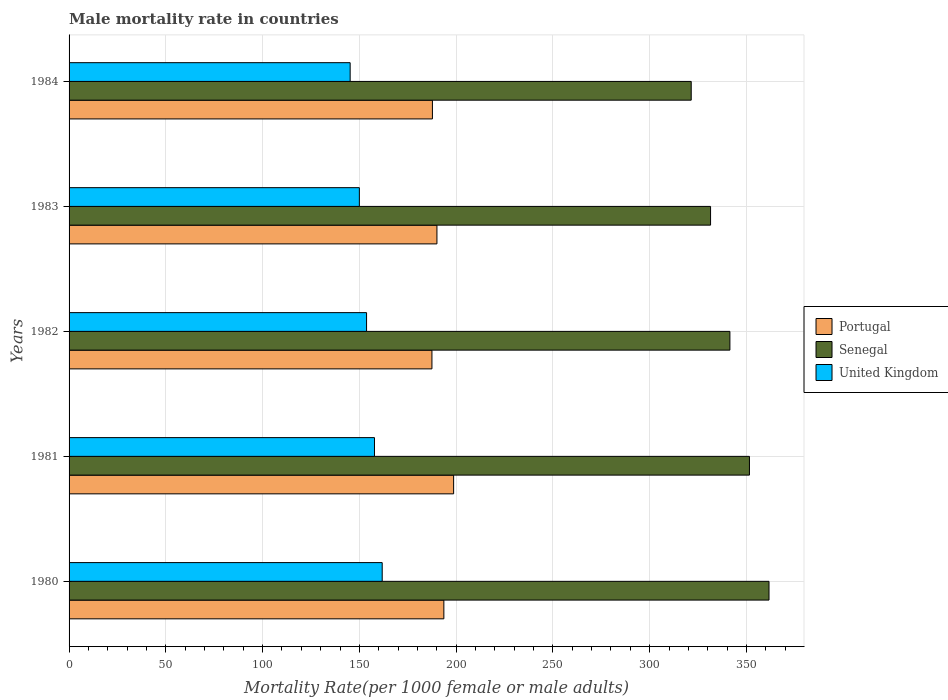How many different coloured bars are there?
Offer a very short reply. 3. Are the number of bars on each tick of the Y-axis equal?
Ensure brevity in your answer.  Yes. What is the label of the 5th group of bars from the top?
Offer a terse response. 1980. What is the male mortality rate in Senegal in 1984?
Make the answer very short. 321.48. Across all years, what is the maximum male mortality rate in Senegal?
Keep it short and to the point. 361.68. Across all years, what is the minimum male mortality rate in Senegal?
Make the answer very short. 321.48. What is the total male mortality rate in Portugal in the graph?
Ensure brevity in your answer.  957.71. What is the difference between the male mortality rate in United Kingdom in 1982 and that in 1983?
Your response must be concise. 3.72. What is the difference between the male mortality rate in Portugal in 1983 and the male mortality rate in Senegal in 1982?
Ensure brevity in your answer.  -151.38. What is the average male mortality rate in Senegal per year?
Make the answer very short. 341.53. In the year 1983, what is the difference between the male mortality rate in Senegal and male mortality rate in United Kingdom?
Give a very brief answer. 181.47. In how many years, is the male mortality rate in Senegal greater than 210 ?
Your answer should be very brief. 5. What is the ratio of the male mortality rate in Portugal in 1982 to that in 1983?
Your answer should be compact. 0.99. What is the difference between the highest and the second highest male mortality rate in Portugal?
Offer a very short reply. 5.04. What is the difference between the highest and the lowest male mortality rate in United Kingdom?
Ensure brevity in your answer.  16.56. Is the sum of the male mortality rate in Senegal in 1982 and 1983 greater than the maximum male mortality rate in Portugal across all years?
Make the answer very short. Yes. What does the 3rd bar from the top in 1984 represents?
Provide a succinct answer. Portugal. What does the 2nd bar from the bottom in 1980 represents?
Make the answer very short. Senegal. How many bars are there?
Offer a very short reply. 15. Are all the bars in the graph horizontal?
Provide a short and direct response. Yes. Are the values on the major ticks of X-axis written in scientific E-notation?
Make the answer very short. No. Does the graph contain grids?
Keep it short and to the point. Yes. Where does the legend appear in the graph?
Provide a succinct answer. Center right. What is the title of the graph?
Your answer should be very brief. Male mortality rate in countries. What is the label or title of the X-axis?
Ensure brevity in your answer.  Mortality Rate(per 1000 female or male adults). What is the label or title of the Y-axis?
Your answer should be very brief. Years. What is the Mortality Rate(per 1000 female or male adults) of Portugal in 1980?
Offer a terse response. 193.66. What is the Mortality Rate(per 1000 female or male adults) of Senegal in 1980?
Your answer should be very brief. 361.68. What is the Mortality Rate(per 1000 female or male adults) in United Kingdom in 1980?
Make the answer very short. 161.8. What is the Mortality Rate(per 1000 female or male adults) of Portugal in 1981?
Your answer should be compact. 198.71. What is the Mortality Rate(per 1000 female or male adults) of Senegal in 1981?
Keep it short and to the point. 351.57. What is the Mortality Rate(per 1000 female or male adults) of United Kingdom in 1981?
Provide a short and direct response. 157.82. What is the Mortality Rate(per 1000 female or male adults) of Portugal in 1982?
Offer a terse response. 187.5. What is the Mortality Rate(per 1000 female or male adults) in Senegal in 1982?
Provide a short and direct response. 341.47. What is the Mortality Rate(per 1000 female or male adults) in United Kingdom in 1982?
Ensure brevity in your answer.  153.72. What is the Mortality Rate(per 1000 female or male adults) in Portugal in 1983?
Your response must be concise. 190.09. What is the Mortality Rate(per 1000 female or male adults) in Senegal in 1983?
Your answer should be compact. 331.47. What is the Mortality Rate(per 1000 female or male adults) in United Kingdom in 1983?
Your answer should be compact. 150. What is the Mortality Rate(per 1000 female or male adults) of Portugal in 1984?
Your answer should be very brief. 187.75. What is the Mortality Rate(per 1000 female or male adults) of Senegal in 1984?
Give a very brief answer. 321.48. What is the Mortality Rate(per 1000 female or male adults) in United Kingdom in 1984?
Provide a short and direct response. 145.24. Across all years, what is the maximum Mortality Rate(per 1000 female or male adults) in Portugal?
Your response must be concise. 198.71. Across all years, what is the maximum Mortality Rate(per 1000 female or male adults) in Senegal?
Give a very brief answer. 361.68. Across all years, what is the maximum Mortality Rate(per 1000 female or male adults) of United Kingdom?
Provide a short and direct response. 161.8. Across all years, what is the minimum Mortality Rate(per 1000 female or male adults) of Portugal?
Provide a short and direct response. 187.5. Across all years, what is the minimum Mortality Rate(per 1000 female or male adults) in Senegal?
Your answer should be compact. 321.48. Across all years, what is the minimum Mortality Rate(per 1000 female or male adults) of United Kingdom?
Give a very brief answer. 145.24. What is the total Mortality Rate(per 1000 female or male adults) in Portugal in the graph?
Your response must be concise. 957.71. What is the total Mortality Rate(per 1000 female or male adults) of Senegal in the graph?
Your answer should be compact. 1707.67. What is the total Mortality Rate(per 1000 female or male adults) of United Kingdom in the graph?
Give a very brief answer. 768.59. What is the difference between the Mortality Rate(per 1000 female or male adults) in Portugal in 1980 and that in 1981?
Make the answer very short. -5.04. What is the difference between the Mortality Rate(per 1000 female or male adults) in Senegal in 1980 and that in 1981?
Your response must be concise. 10.1. What is the difference between the Mortality Rate(per 1000 female or male adults) of United Kingdom in 1980 and that in 1981?
Keep it short and to the point. 3.99. What is the difference between the Mortality Rate(per 1000 female or male adults) in Portugal in 1980 and that in 1982?
Your answer should be compact. 6.16. What is the difference between the Mortality Rate(per 1000 female or male adults) in Senegal in 1980 and that in 1982?
Make the answer very short. 20.21. What is the difference between the Mortality Rate(per 1000 female or male adults) of United Kingdom in 1980 and that in 1982?
Your response must be concise. 8.08. What is the difference between the Mortality Rate(per 1000 female or male adults) of Portugal in 1980 and that in 1983?
Your answer should be compact. 3.57. What is the difference between the Mortality Rate(per 1000 female or male adults) in Senegal in 1980 and that in 1983?
Your response must be concise. 30.2. What is the difference between the Mortality Rate(per 1000 female or male adults) in United Kingdom in 1980 and that in 1983?
Your answer should be compact. 11.8. What is the difference between the Mortality Rate(per 1000 female or male adults) of Portugal in 1980 and that in 1984?
Offer a terse response. 5.91. What is the difference between the Mortality Rate(per 1000 female or male adults) of Senegal in 1980 and that in 1984?
Give a very brief answer. 40.2. What is the difference between the Mortality Rate(per 1000 female or male adults) of United Kingdom in 1980 and that in 1984?
Make the answer very short. 16.56. What is the difference between the Mortality Rate(per 1000 female or male adults) of Portugal in 1981 and that in 1982?
Your answer should be very brief. 11.21. What is the difference between the Mortality Rate(per 1000 female or male adults) in Senegal in 1981 and that in 1982?
Your answer should be compact. 10.1. What is the difference between the Mortality Rate(per 1000 female or male adults) of United Kingdom in 1981 and that in 1982?
Offer a very short reply. 4.09. What is the difference between the Mortality Rate(per 1000 female or male adults) of Portugal in 1981 and that in 1983?
Offer a terse response. 8.62. What is the difference between the Mortality Rate(per 1000 female or male adults) of Senegal in 1981 and that in 1983?
Make the answer very short. 20.1. What is the difference between the Mortality Rate(per 1000 female or male adults) in United Kingdom in 1981 and that in 1983?
Your answer should be compact. 7.81. What is the difference between the Mortality Rate(per 1000 female or male adults) in Portugal in 1981 and that in 1984?
Provide a succinct answer. 10.95. What is the difference between the Mortality Rate(per 1000 female or male adults) of Senegal in 1981 and that in 1984?
Ensure brevity in your answer.  30.09. What is the difference between the Mortality Rate(per 1000 female or male adults) of United Kingdom in 1981 and that in 1984?
Make the answer very short. 12.57. What is the difference between the Mortality Rate(per 1000 female or male adults) of Portugal in 1982 and that in 1983?
Provide a succinct answer. -2.59. What is the difference between the Mortality Rate(per 1000 female or male adults) in Senegal in 1982 and that in 1983?
Offer a terse response. 9.99. What is the difference between the Mortality Rate(per 1000 female or male adults) of United Kingdom in 1982 and that in 1983?
Give a very brief answer. 3.72. What is the difference between the Mortality Rate(per 1000 female or male adults) in Portugal in 1982 and that in 1984?
Your answer should be very brief. -0.26. What is the difference between the Mortality Rate(per 1000 female or male adults) in Senegal in 1982 and that in 1984?
Give a very brief answer. 19.99. What is the difference between the Mortality Rate(per 1000 female or male adults) in United Kingdom in 1982 and that in 1984?
Your answer should be compact. 8.48. What is the difference between the Mortality Rate(per 1000 female or male adults) in Portugal in 1983 and that in 1984?
Give a very brief answer. 2.33. What is the difference between the Mortality Rate(per 1000 female or male adults) in Senegal in 1983 and that in 1984?
Give a very brief answer. 9.99. What is the difference between the Mortality Rate(per 1000 female or male adults) in United Kingdom in 1983 and that in 1984?
Your response must be concise. 4.76. What is the difference between the Mortality Rate(per 1000 female or male adults) in Portugal in 1980 and the Mortality Rate(per 1000 female or male adults) in Senegal in 1981?
Your response must be concise. -157.91. What is the difference between the Mortality Rate(per 1000 female or male adults) of Portugal in 1980 and the Mortality Rate(per 1000 female or male adults) of United Kingdom in 1981?
Keep it short and to the point. 35.84. What is the difference between the Mortality Rate(per 1000 female or male adults) in Senegal in 1980 and the Mortality Rate(per 1000 female or male adults) in United Kingdom in 1981?
Make the answer very short. 203.86. What is the difference between the Mortality Rate(per 1000 female or male adults) in Portugal in 1980 and the Mortality Rate(per 1000 female or male adults) in Senegal in 1982?
Your answer should be compact. -147.81. What is the difference between the Mortality Rate(per 1000 female or male adults) of Portugal in 1980 and the Mortality Rate(per 1000 female or male adults) of United Kingdom in 1982?
Your response must be concise. 39.94. What is the difference between the Mortality Rate(per 1000 female or male adults) of Senegal in 1980 and the Mortality Rate(per 1000 female or male adults) of United Kingdom in 1982?
Your response must be concise. 207.95. What is the difference between the Mortality Rate(per 1000 female or male adults) in Portugal in 1980 and the Mortality Rate(per 1000 female or male adults) in Senegal in 1983?
Keep it short and to the point. -137.81. What is the difference between the Mortality Rate(per 1000 female or male adults) of Portugal in 1980 and the Mortality Rate(per 1000 female or male adults) of United Kingdom in 1983?
Make the answer very short. 43.66. What is the difference between the Mortality Rate(per 1000 female or male adults) of Senegal in 1980 and the Mortality Rate(per 1000 female or male adults) of United Kingdom in 1983?
Your response must be concise. 211.67. What is the difference between the Mortality Rate(per 1000 female or male adults) of Portugal in 1980 and the Mortality Rate(per 1000 female or male adults) of Senegal in 1984?
Offer a very short reply. -127.82. What is the difference between the Mortality Rate(per 1000 female or male adults) in Portugal in 1980 and the Mortality Rate(per 1000 female or male adults) in United Kingdom in 1984?
Your answer should be very brief. 48.42. What is the difference between the Mortality Rate(per 1000 female or male adults) of Senegal in 1980 and the Mortality Rate(per 1000 female or male adults) of United Kingdom in 1984?
Provide a succinct answer. 216.43. What is the difference between the Mortality Rate(per 1000 female or male adults) in Portugal in 1981 and the Mortality Rate(per 1000 female or male adults) in Senegal in 1982?
Make the answer very short. -142.76. What is the difference between the Mortality Rate(per 1000 female or male adults) of Portugal in 1981 and the Mortality Rate(per 1000 female or male adults) of United Kingdom in 1982?
Keep it short and to the point. 44.98. What is the difference between the Mortality Rate(per 1000 female or male adults) of Senegal in 1981 and the Mortality Rate(per 1000 female or male adults) of United Kingdom in 1982?
Give a very brief answer. 197.85. What is the difference between the Mortality Rate(per 1000 female or male adults) of Portugal in 1981 and the Mortality Rate(per 1000 female or male adults) of Senegal in 1983?
Provide a succinct answer. -132.77. What is the difference between the Mortality Rate(per 1000 female or male adults) of Portugal in 1981 and the Mortality Rate(per 1000 female or male adults) of United Kingdom in 1983?
Offer a terse response. 48.7. What is the difference between the Mortality Rate(per 1000 female or male adults) in Senegal in 1981 and the Mortality Rate(per 1000 female or male adults) in United Kingdom in 1983?
Your answer should be compact. 201.57. What is the difference between the Mortality Rate(per 1000 female or male adults) in Portugal in 1981 and the Mortality Rate(per 1000 female or male adults) in Senegal in 1984?
Give a very brief answer. -122.77. What is the difference between the Mortality Rate(per 1000 female or male adults) of Portugal in 1981 and the Mortality Rate(per 1000 female or male adults) of United Kingdom in 1984?
Provide a short and direct response. 53.46. What is the difference between the Mortality Rate(per 1000 female or male adults) in Senegal in 1981 and the Mortality Rate(per 1000 female or male adults) in United Kingdom in 1984?
Your response must be concise. 206.33. What is the difference between the Mortality Rate(per 1000 female or male adults) of Portugal in 1982 and the Mortality Rate(per 1000 female or male adults) of Senegal in 1983?
Your answer should be very brief. -143.98. What is the difference between the Mortality Rate(per 1000 female or male adults) of Portugal in 1982 and the Mortality Rate(per 1000 female or male adults) of United Kingdom in 1983?
Ensure brevity in your answer.  37.49. What is the difference between the Mortality Rate(per 1000 female or male adults) in Senegal in 1982 and the Mortality Rate(per 1000 female or male adults) in United Kingdom in 1983?
Provide a short and direct response. 191.47. What is the difference between the Mortality Rate(per 1000 female or male adults) of Portugal in 1982 and the Mortality Rate(per 1000 female or male adults) of Senegal in 1984?
Your answer should be very brief. -133.98. What is the difference between the Mortality Rate(per 1000 female or male adults) in Portugal in 1982 and the Mortality Rate(per 1000 female or male adults) in United Kingdom in 1984?
Give a very brief answer. 42.25. What is the difference between the Mortality Rate(per 1000 female or male adults) in Senegal in 1982 and the Mortality Rate(per 1000 female or male adults) in United Kingdom in 1984?
Your response must be concise. 196.22. What is the difference between the Mortality Rate(per 1000 female or male adults) of Portugal in 1983 and the Mortality Rate(per 1000 female or male adults) of Senegal in 1984?
Your response must be concise. -131.39. What is the difference between the Mortality Rate(per 1000 female or male adults) of Portugal in 1983 and the Mortality Rate(per 1000 female or male adults) of United Kingdom in 1984?
Offer a very short reply. 44.84. What is the difference between the Mortality Rate(per 1000 female or male adults) in Senegal in 1983 and the Mortality Rate(per 1000 female or male adults) in United Kingdom in 1984?
Offer a very short reply. 186.23. What is the average Mortality Rate(per 1000 female or male adults) of Portugal per year?
Keep it short and to the point. 191.54. What is the average Mortality Rate(per 1000 female or male adults) of Senegal per year?
Offer a terse response. 341.53. What is the average Mortality Rate(per 1000 female or male adults) in United Kingdom per year?
Provide a short and direct response. 153.72. In the year 1980, what is the difference between the Mortality Rate(per 1000 female or male adults) in Portugal and Mortality Rate(per 1000 female or male adults) in Senegal?
Ensure brevity in your answer.  -168.01. In the year 1980, what is the difference between the Mortality Rate(per 1000 female or male adults) in Portugal and Mortality Rate(per 1000 female or male adults) in United Kingdom?
Give a very brief answer. 31.86. In the year 1980, what is the difference between the Mortality Rate(per 1000 female or male adults) of Senegal and Mortality Rate(per 1000 female or male adults) of United Kingdom?
Keep it short and to the point. 199.87. In the year 1981, what is the difference between the Mortality Rate(per 1000 female or male adults) of Portugal and Mortality Rate(per 1000 female or male adults) of Senegal?
Offer a very short reply. -152.87. In the year 1981, what is the difference between the Mortality Rate(per 1000 female or male adults) in Portugal and Mortality Rate(per 1000 female or male adults) in United Kingdom?
Keep it short and to the point. 40.89. In the year 1981, what is the difference between the Mortality Rate(per 1000 female or male adults) of Senegal and Mortality Rate(per 1000 female or male adults) of United Kingdom?
Your response must be concise. 193.75. In the year 1982, what is the difference between the Mortality Rate(per 1000 female or male adults) of Portugal and Mortality Rate(per 1000 female or male adults) of Senegal?
Give a very brief answer. -153.97. In the year 1982, what is the difference between the Mortality Rate(per 1000 female or male adults) of Portugal and Mortality Rate(per 1000 female or male adults) of United Kingdom?
Offer a terse response. 33.77. In the year 1982, what is the difference between the Mortality Rate(per 1000 female or male adults) in Senegal and Mortality Rate(per 1000 female or male adults) in United Kingdom?
Make the answer very short. 187.74. In the year 1983, what is the difference between the Mortality Rate(per 1000 female or male adults) of Portugal and Mortality Rate(per 1000 female or male adults) of Senegal?
Provide a short and direct response. -141.38. In the year 1983, what is the difference between the Mortality Rate(per 1000 female or male adults) of Portugal and Mortality Rate(per 1000 female or male adults) of United Kingdom?
Give a very brief answer. 40.09. In the year 1983, what is the difference between the Mortality Rate(per 1000 female or male adults) of Senegal and Mortality Rate(per 1000 female or male adults) of United Kingdom?
Your response must be concise. 181.47. In the year 1984, what is the difference between the Mortality Rate(per 1000 female or male adults) of Portugal and Mortality Rate(per 1000 female or male adults) of Senegal?
Make the answer very short. -133.72. In the year 1984, what is the difference between the Mortality Rate(per 1000 female or male adults) of Portugal and Mortality Rate(per 1000 female or male adults) of United Kingdom?
Offer a terse response. 42.51. In the year 1984, what is the difference between the Mortality Rate(per 1000 female or male adults) in Senegal and Mortality Rate(per 1000 female or male adults) in United Kingdom?
Your response must be concise. 176.24. What is the ratio of the Mortality Rate(per 1000 female or male adults) of Portugal in 1980 to that in 1981?
Provide a short and direct response. 0.97. What is the ratio of the Mortality Rate(per 1000 female or male adults) in Senegal in 1980 to that in 1981?
Give a very brief answer. 1.03. What is the ratio of the Mortality Rate(per 1000 female or male adults) of United Kingdom in 1980 to that in 1981?
Keep it short and to the point. 1.03. What is the ratio of the Mortality Rate(per 1000 female or male adults) of Portugal in 1980 to that in 1982?
Keep it short and to the point. 1.03. What is the ratio of the Mortality Rate(per 1000 female or male adults) in Senegal in 1980 to that in 1982?
Provide a succinct answer. 1.06. What is the ratio of the Mortality Rate(per 1000 female or male adults) in United Kingdom in 1980 to that in 1982?
Offer a terse response. 1.05. What is the ratio of the Mortality Rate(per 1000 female or male adults) in Portugal in 1980 to that in 1983?
Offer a very short reply. 1.02. What is the ratio of the Mortality Rate(per 1000 female or male adults) of Senegal in 1980 to that in 1983?
Give a very brief answer. 1.09. What is the ratio of the Mortality Rate(per 1000 female or male adults) of United Kingdom in 1980 to that in 1983?
Provide a succinct answer. 1.08. What is the ratio of the Mortality Rate(per 1000 female or male adults) in Portugal in 1980 to that in 1984?
Your answer should be very brief. 1.03. What is the ratio of the Mortality Rate(per 1000 female or male adults) of Senegal in 1980 to that in 1984?
Provide a succinct answer. 1.12. What is the ratio of the Mortality Rate(per 1000 female or male adults) in United Kingdom in 1980 to that in 1984?
Ensure brevity in your answer.  1.11. What is the ratio of the Mortality Rate(per 1000 female or male adults) in Portugal in 1981 to that in 1982?
Your answer should be compact. 1.06. What is the ratio of the Mortality Rate(per 1000 female or male adults) in Senegal in 1981 to that in 1982?
Your answer should be compact. 1.03. What is the ratio of the Mortality Rate(per 1000 female or male adults) of United Kingdom in 1981 to that in 1982?
Offer a very short reply. 1.03. What is the ratio of the Mortality Rate(per 1000 female or male adults) of Portugal in 1981 to that in 1983?
Your answer should be very brief. 1.05. What is the ratio of the Mortality Rate(per 1000 female or male adults) of Senegal in 1981 to that in 1983?
Keep it short and to the point. 1.06. What is the ratio of the Mortality Rate(per 1000 female or male adults) in United Kingdom in 1981 to that in 1983?
Offer a terse response. 1.05. What is the ratio of the Mortality Rate(per 1000 female or male adults) of Portugal in 1981 to that in 1984?
Your answer should be very brief. 1.06. What is the ratio of the Mortality Rate(per 1000 female or male adults) in Senegal in 1981 to that in 1984?
Offer a terse response. 1.09. What is the ratio of the Mortality Rate(per 1000 female or male adults) in United Kingdom in 1981 to that in 1984?
Offer a very short reply. 1.09. What is the ratio of the Mortality Rate(per 1000 female or male adults) in Portugal in 1982 to that in 1983?
Your answer should be very brief. 0.99. What is the ratio of the Mortality Rate(per 1000 female or male adults) in Senegal in 1982 to that in 1983?
Your answer should be compact. 1.03. What is the ratio of the Mortality Rate(per 1000 female or male adults) in United Kingdom in 1982 to that in 1983?
Provide a succinct answer. 1.02. What is the ratio of the Mortality Rate(per 1000 female or male adults) in Portugal in 1982 to that in 1984?
Provide a succinct answer. 1. What is the ratio of the Mortality Rate(per 1000 female or male adults) in Senegal in 1982 to that in 1984?
Your answer should be very brief. 1.06. What is the ratio of the Mortality Rate(per 1000 female or male adults) of United Kingdom in 1982 to that in 1984?
Provide a short and direct response. 1.06. What is the ratio of the Mortality Rate(per 1000 female or male adults) of Portugal in 1983 to that in 1984?
Provide a short and direct response. 1.01. What is the ratio of the Mortality Rate(per 1000 female or male adults) of Senegal in 1983 to that in 1984?
Your answer should be compact. 1.03. What is the ratio of the Mortality Rate(per 1000 female or male adults) of United Kingdom in 1983 to that in 1984?
Provide a short and direct response. 1.03. What is the difference between the highest and the second highest Mortality Rate(per 1000 female or male adults) of Portugal?
Offer a terse response. 5.04. What is the difference between the highest and the second highest Mortality Rate(per 1000 female or male adults) in Senegal?
Offer a very short reply. 10.1. What is the difference between the highest and the second highest Mortality Rate(per 1000 female or male adults) in United Kingdom?
Your response must be concise. 3.99. What is the difference between the highest and the lowest Mortality Rate(per 1000 female or male adults) of Portugal?
Offer a terse response. 11.21. What is the difference between the highest and the lowest Mortality Rate(per 1000 female or male adults) of Senegal?
Keep it short and to the point. 40.2. What is the difference between the highest and the lowest Mortality Rate(per 1000 female or male adults) of United Kingdom?
Ensure brevity in your answer.  16.56. 